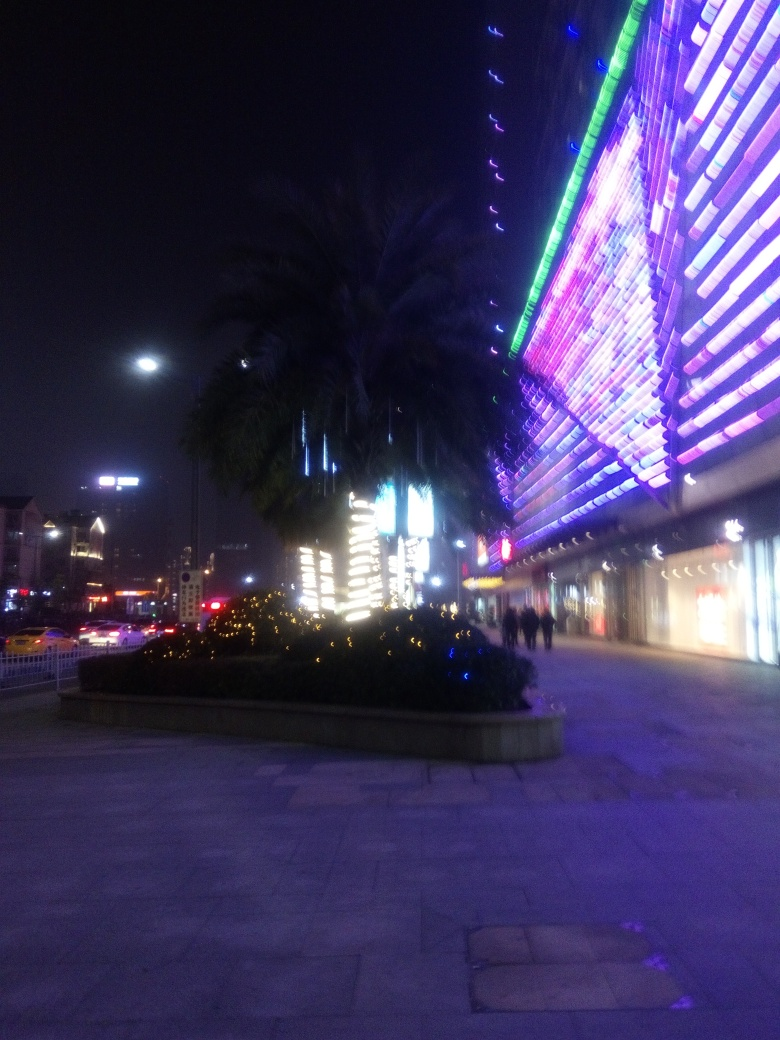Could you infer what kind of area is pictured in the image? Commercial, residential, or something else? The image seems to depict a commercial area, as evidenced by storefronts with bright signage and neon advertisements. The wide pedestrian walkways and absence of residential features further suggest that this is an area designed for shopping and entertainment rather than living spaces. 